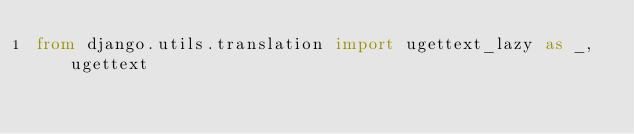Convert code to text. <code><loc_0><loc_0><loc_500><loc_500><_Python_>from django.utils.translation import ugettext_lazy as _, ugettext


</code> 